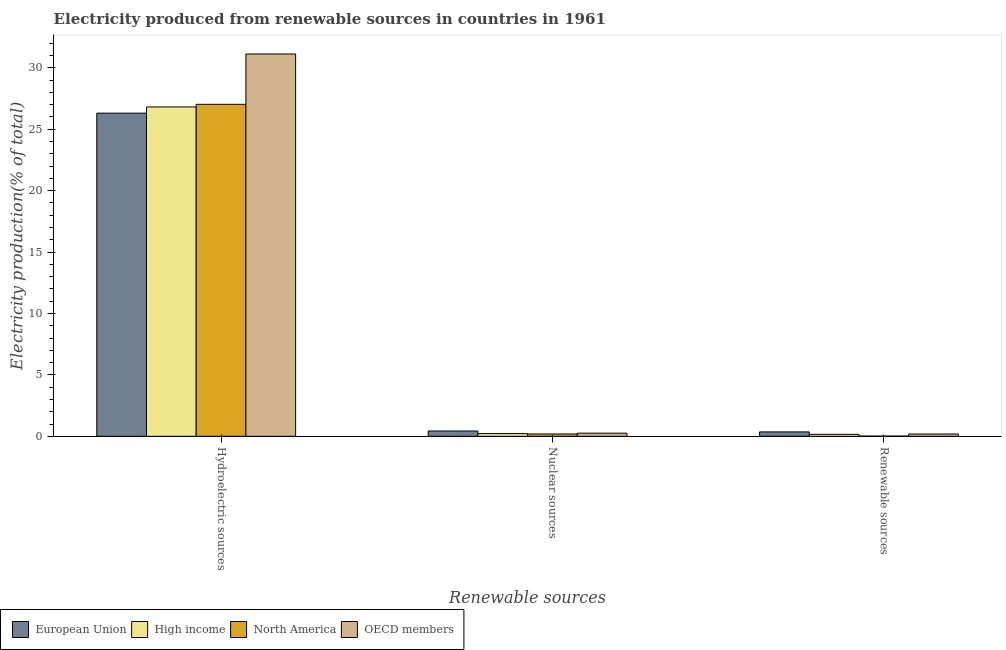How many groups of bars are there?
Your answer should be very brief. 3. How many bars are there on the 1st tick from the left?
Make the answer very short. 4. What is the label of the 1st group of bars from the left?
Make the answer very short. Hydroelectric sources. What is the percentage of electricity produced by renewable sources in North America?
Your response must be concise. 0.02. Across all countries, what is the maximum percentage of electricity produced by renewable sources?
Make the answer very short. 0.36. Across all countries, what is the minimum percentage of electricity produced by hydroelectric sources?
Give a very brief answer. 26.31. What is the total percentage of electricity produced by nuclear sources in the graph?
Your answer should be very brief. 1.1. What is the difference between the percentage of electricity produced by renewable sources in OECD members and that in European Union?
Provide a succinct answer. -0.17. What is the difference between the percentage of electricity produced by hydroelectric sources in North America and the percentage of electricity produced by renewable sources in European Union?
Provide a succinct answer. 26.66. What is the average percentage of electricity produced by hydroelectric sources per country?
Make the answer very short. 27.82. What is the difference between the percentage of electricity produced by hydroelectric sources and percentage of electricity produced by renewable sources in North America?
Your response must be concise. 27.01. In how many countries, is the percentage of electricity produced by nuclear sources greater than 15 %?
Your response must be concise. 0. What is the ratio of the percentage of electricity produced by nuclear sources in European Union to that in High income?
Offer a terse response. 1.96. What is the difference between the highest and the second highest percentage of electricity produced by hydroelectric sources?
Keep it short and to the point. 4.1. What is the difference between the highest and the lowest percentage of electricity produced by renewable sources?
Ensure brevity in your answer.  0.34. In how many countries, is the percentage of electricity produced by renewable sources greater than the average percentage of electricity produced by renewable sources taken over all countries?
Ensure brevity in your answer.  2. Is the sum of the percentage of electricity produced by hydroelectric sources in High income and European Union greater than the maximum percentage of electricity produced by renewable sources across all countries?
Your response must be concise. Yes. What does the 3rd bar from the right in Hydroelectric sources represents?
Your answer should be compact. High income. Is it the case that in every country, the sum of the percentage of electricity produced by hydroelectric sources and percentage of electricity produced by nuclear sources is greater than the percentage of electricity produced by renewable sources?
Your response must be concise. Yes. How many bars are there?
Your answer should be compact. 12. How many countries are there in the graph?
Give a very brief answer. 4. What is the difference between two consecutive major ticks on the Y-axis?
Ensure brevity in your answer.  5. Are the values on the major ticks of Y-axis written in scientific E-notation?
Give a very brief answer. No. Does the graph contain any zero values?
Make the answer very short. No. Does the graph contain grids?
Provide a succinct answer. No. How are the legend labels stacked?
Your answer should be very brief. Horizontal. What is the title of the graph?
Offer a very short reply. Electricity produced from renewable sources in countries in 1961. Does "Montenegro" appear as one of the legend labels in the graph?
Your response must be concise. No. What is the label or title of the X-axis?
Make the answer very short. Renewable sources. What is the label or title of the Y-axis?
Your response must be concise. Electricity production(% of total). What is the Electricity production(% of total) in European Union in Hydroelectric sources?
Offer a very short reply. 26.31. What is the Electricity production(% of total) of High income in Hydroelectric sources?
Keep it short and to the point. 26.81. What is the Electricity production(% of total) of North America in Hydroelectric sources?
Make the answer very short. 27.02. What is the Electricity production(% of total) of OECD members in Hydroelectric sources?
Give a very brief answer. 31.12. What is the Electricity production(% of total) in European Union in Nuclear sources?
Ensure brevity in your answer.  0.43. What is the Electricity production(% of total) of High income in Nuclear sources?
Keep it short and to the point. 0.22. What is the Electricity production(% of total) in North America in Nuclear sources?
Offer a terse response. 0.19. What is the Electricity production(% of total) of OECD members in Nuclear sources?
Offer a terse response. 0.26. What is the Electricity production(% of total) in European Union in Renewable sources?
Give a very brief answer. 0.36. What is the Electricity production(% of total) in High income in Renewable sources?
Your answer should be very brief. 0.16. What is the Electricity production(% of total) of North America in Renewable sources?
Make the answer very short. 0.02. What is the Electricity production(% of total) of OECD members in Renewable sources?
Offer a terse response. 0.19. Across all Renewable sources, what is the maximum Electricity production(% of total) of European Union?
Your response must be concise. 26.31. Across all Renewable sources, what is the maximum Electricity production(% of total) of High income?
Give a very brief answer. 26.81. Across all Renewable sources, what is the maximum Electricity production(% of total) in North America?
Your answer should be compact. 27.02. Across all Renewable sources, what is the maximum Electricity production(% of total) in OECD members?
Offer a very short reply. 31.12. Across all Renewable sources, what is the minimum Electricity production(% of total) in European Union?
Give a very brief answer. 0.36. Across all Renewable sources, what is the minimum Electricity production(% of total) of High income?
Your answer should be very brief. 0.16. Across all Renewable sources, what is the minimum Electricity production(% of total) of North America?
Make the answer very short. 0.02. Across all Renewable sources, what is the minimum Electricity production(% of total) of OECD members?
Give a very brief answer. 0.19. What is the total Electricity production(% of total) in European Union in the graph?
Your answer should be very brief. 27.1. What is the total Electricity production(% of total) of High income in the graph?
Provide a short and direct response. 27.19. What is the total Electricity production(% of total) in North America in the graph?
Your answer should be compact. 27.23. What is the total Electricity production(% of total) of OECD members in the graph?
Offer a terse response. 31.57. What is the difference between the Electricity production(% of total) in European Union in Hydroelectric sources and that in Nuclear sources?
Your answer should be compact. 25.87. What is the difference between the Electricity production(% of total) of High income in Hydroelectric sources and that in Nuclear sources?
Offer a terse response. 26.59. What is the difference between the Electricity production(% of total) in North America in Hydroelectric sources and that in Nuclear sources?
Keep it short and to the point. 26.84. What is the difference between the Electricity production(% of total) in OECD members in Hydroelectric sources and that in Nuclear sources?
Offer a very short reply. 30.87. What is the difference between the Electricity production(% of total) in European Union in Hydroelectric sources and that in Renewable sources?
Your response must be concise. 25.95. What is the difference between the Electricity production(% of total) of High income in Hydroelectric sources and that in Renewable sources?
Your answer should be compact. 26.65. What is the difference between the Electricity production(% of total) in North America in Hydroelectric sources and that in Renewable sources?
Give a very brief answer. 27.01. What is the difference between the Electricity production(% of total) of OECD members in Hydroelectric sources and that in Renewable sources?
Offer a terse response. 30.93. What is the difference between the Electricity production(% of total) in European Union in Nuclear sources and that in Renewable sources?
Give a very brief answer. 0.07. What is the difference between the Electricity production(% of total) in High income in Nuclear sources and that in Renewable sources?
Your answer should be very brief. 0.06. What is the difference between the Electricity production(% of total) in North America in Nuclear sources and that in Renewable sources?
Provide a short and direct response. 0.17. What is the difference between the Electricity production(% of total) of OECD members in Nuclear sources and that in Renewable sources?
Provide a succinct answer. 0.07. What is the difference between the Electricity production(% of total) in European Union in Hydroelectric sources and the Electricity production(% of total) in High income in Nuclear sources?
Offer a terse response. 26.09. What is the difference between the Electricity production(% of total) of European Union in Hydroelectric sources and the Electricity production(% of total) of North America in Nuclear sources?
Your answer should be compact. 26.12. What is the difference between the Electricity production(% of total) in European Union in Hydroelectric sources and the Electricity production(% of total) in OECD members in Nuclear sources?
Ensure brevity in your answer.  26.05. What is the difference between the Electricity production(% of total) of High income in Hydroelectric sources and the Electricity production(% of total) of North America in Nuclear sources?
Ensure brevity in your answer.  26.62. What is the difference between the Electricity production(% of total) of High income in Hydroelectric sources and the Electricity production(% of total) of OECD members in Nuclear sources?
Provide a succinct answer. 26.56. What is the difference between the Electricity production(% of total) in North America in Hydroelectric sources and the Electricity production(% of total) in OECD members in Nuclear sources?
Provide a short and direct response. 26.77. What is the difference between the Electricity production(% of total) in European Union in Hydroelectric sources and the Electricity production(% of total) in High income in Renewable sources?
Your response must be concise. 26.15. What is the difference between the Electricity production(% of total) in European Union in Hydroelectric sources and the Electricity production(% of total) in North America in Renewable sources?
Your answer should be compact. 26.29. What is the difference between the Electricity production(% of total) in European Union in Hydroelectric sources and the Electricity production(% of total) in OECD members in Renewable sources?
Ensure brevity in your answer.  26.12. What is the difference between the Electricity production(% of total) of High income in Hydroelectric sources and the Electricity production(% of total) of North America in Renewable sources?
Make the answer very short. 26.79. What is the difference between the Electricity production(% of total) of High income in Hydroelectric sources and the Electricity production(% of total) of OECD members in Renewable sources?
Give a very brief answer. 26.62. What is the difference between the Electricity production(% of total) of North America in Hydroelectric sources and the Electricity production(% of total) of OECD members in Renewable sources?
Offer a terse response. 26.84. What is the difference between the Electricity production(% of total) of European Union in Nuclear sources and the Electricity production(% of total) of High income in Renewable sources?
Your response must be concise. 0.27. What is the difference between the Electricity production(% of total) in European Union in Nuclear sources and the Electricity production(% of total) in North America in Renewable sources?
Offer a very short reply. 0.41. What is the difference between the Electricity production(% of total) of European Union in Nuclear sources and the Electricity production(% of total) of OECD members in Renewable sources?
Offer a terse response. 0.25. What is the difference between the Electricity production(% of total) in High income in Nuclear sources and the Electricity production(% of total) in North America in Renewable sources?
Give a very brief answer. 0.2. What is the difference between the Electricity production(% of total) of High income in Nuclear sources and the Electricity production(% of total) of OECD members in Renewable sources?
Your answer should be very brief. 0.03. What is the difference between the Electricity production(% of total) in North America in Nuclear sources and the Electricity production(% of total) in OECD members in Renewable sources?
Offer a terse response. 0. What is the average Electricity production(% of total) of European Union per Renewable sources?
Make the answer very short. 9.03. What is the average Electricity production(% of total) of High income per Renewable sources?
Your answer should be very brief. 9.06. What is the average Electricity production(% of total) of North America per Renewable sources?
Offer a terse response. 9.08. What is the average Electricity production(% of total) in OECD members per Renewable sources?
Your answer should be very brief. 10.52. What is the difference between the Electricity production(% of total) in European Union and Electricity production(% of total) in High income in Hydroelectric sources?
Your response must be concise. -0.51. What is the difference between the Electricity production(% of total) in European Union and Electricity production(% of total) in North America in Hydroelectric sources?
Offer a terse response. -0.72. What is the difference between the Electricity production(% of total) in European Union and Electricity production(% of total) in OECD members in Hydroelectric sources?
Your answer should be compact. -4.82. What is the difference between the Electricity production(% of total) of High income and Electricity production(% of total) of North America in Hydroelectric sources?
Your answer should be compact. -0.21. What is the difference between the Electricity production(% of total) in High income and Electricity production(% of total) in OECD members in Hydroelectric sources?
Ensure brevity in your answer.  -4.31. What is the difference between the Electricity production(% of total) of North America and Electricity production(% of total) of OECD members in Hydroelectric sources?
Give a very brief answer. -4.1. What is the difference between the Electricity production(% of total) of European Union and Electricity production(% of total) of High income in Nuclear sources?
Provide a short and direct response. 0.21. What is the difference between the Electricity production(% of total) in European Union and Electricity production(% of total) in North America in Nuclear sources?
Provide a succinct answer. 0.24. What is the difference between the Electricity production(% of total) of European Union and Electricity production(% of total) of OECD members in Nuclear sources?
Make the answer very short. 0.18. What is the difference between the Electricity production(% of total) of High income and Electricity production(% of total) of North America in Nuclear sources?
Provide a succinct answer. 0.03. What is the difference between the Electricity production(% of total) of High income and Electricity production(% of total) of OECD members in Nuclear sources?
Offer a very short reply. -0.03. What is the difference between the Electricity production(% of total) in North America and Electricity production(% of total) in OECD members in Nuclear sources?
Your answer should be very brief. -0.07. What is the difference between the Electricity production(% of total) of European Union and Electricity production(% of total) of High income in Renewable sources?
Make the answer very short. 0.2. What is the difference between the Electricity production(% of total) of European Union and Electricity production(% of total) of North America in Renewable sources?
Ensure brevity in your answer.  0.34. What is the difference between the Electricity production(% of total) of European Union and Electricity production(% of total) of OECD members in Renewable sources?
Give a very brief answer. 0.17. What is the difference between the Electricity production(% of total) of High income and Electricity production(% of total) of North America in Renewable sources?
Give a very brief answer. 0.14. What is the difference between the Electricity production(% of total) in High income and Electricity production(% of total) in OECD members in Renewable sources?
Your response must be concise. -0.03. What is the difference between the Electricity production(% of total) in North America and Electricity production(% of total) in OECD members in Renewable sources?
Make the answer very short. -0.17. What is the ratio of the Electricity production(% of total) in European Union in Hydroelectric sources to that in Nuclear sources?
Provide a succinct answer. 60.68. What is the ratio of the Electricity production(% of total) of High income in Hydroelectric sources to that in Nuclear sources?
Offer a very short reply. 121.31. What is the ratio of the Electricity production(% of total) of North America in Hydroelectric sources to that in Nuclear sources?
Offer a very short reply. 142.88. What is the ratio of the Electricity production(% of total) of OECD members in Hydroelectric sources to that in Nuclear sources?
Your response must be concise. 121.58. What is the ratio of the Electricity production(% of total) of European Union in Hydroelectric sources to that in Renewable sources?
Provide a succinct answer. 73.09. What is the ratio of the Electricity production(% of total) of High income in Hydroelectric sources to that in Renewable sources?
Keep it short and to the point. 167.41. What is the ratio of the Electricity production(% of total) in North America in Hydroelectric sources to that in Renewable sources?
Make the answer very short. 1427.27. What is the ratio of the Electricity production(% of total) in OECD members in Hydroelectric sources to that in Renewable sources?
Offer a very short reply. 165.63. What is the ratio of the Electricity production(% of total) in European Union in Nuclear sources to that in Renewable sources?
Your response must be concise. 1.2. What is the ratio of the Electricity production(% of total) in High income in Nuclear sources to that in Renewable sources?
Offer a terse response. 1.38. What is the ratio of the Electricity production(% of total) of North America in Nuclear sources to that in Renewable sources?
Provide a short and direct response. 9.99. What is the ratio of the Electricity production(% of total) in OECD members in Nuclear sources to that in Renewable sources?
Your answer should be very brief. 1.36. What is the difference between the highest and the second highest Electricity production(% of total) of European Union?
Offer a terse response. 25.87. What is the difference between the highest and the second highest Electricity production(% of total) of High income?
Provide a short and direct response. 26.59. What is the difference between the highest and the second highest Electricity production(% of total) in North America?
Your answer should be compact. 26.84. What is the difference between the highest and the second highest Electricity production(% of total) of OECD members?
Provide a short and direct response. 30.87. What is the difference between the highest and the lowest Electricity production(% of total) of European Union?
Make the answer very short. 25.95. What is the difference between the highest and the lowest Electricity production(% of total) in High income?
Provide a succinct answer. 26.65. What is the difference between the highest and the lowest Electricity production(% of total) of North America?
Your answer should be compact. 27.01. What is the difference between the highest and the lowest Electricity production(% of total) of OECD members?
Keep it short and to the point. 30.93. 